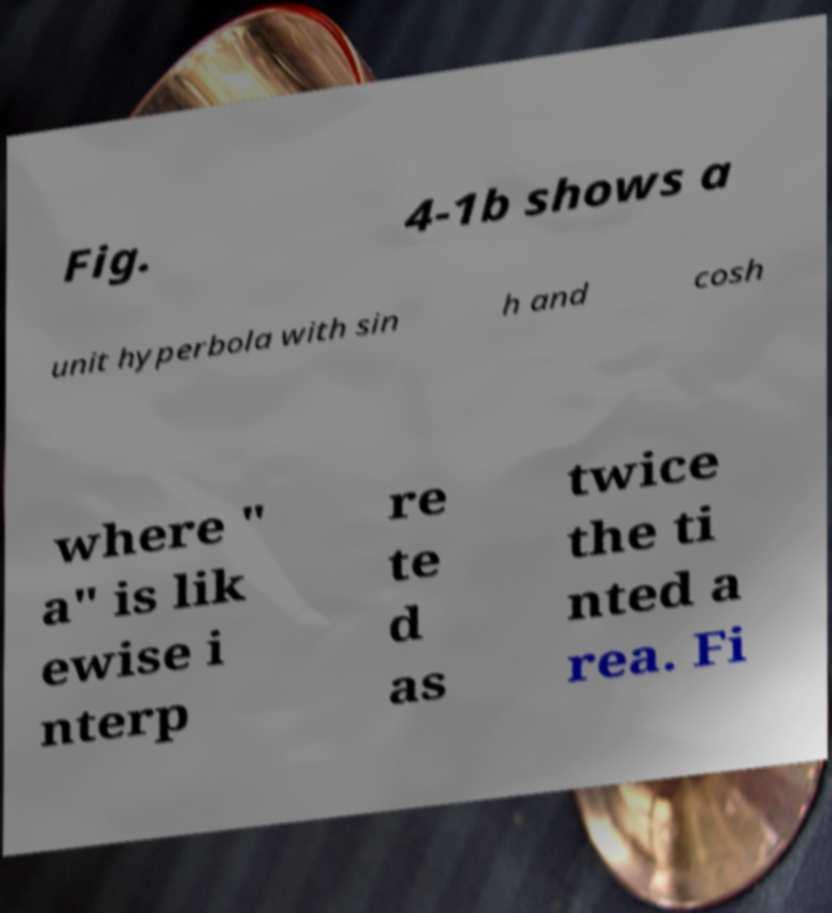Please read and relay the text visible in this image. What does it say? Fig. 4-1b shows a unit hyperbola with sin h and cosh where " a" is lik ewise i nterp re te d as twice the ti nted a rea. Fi 